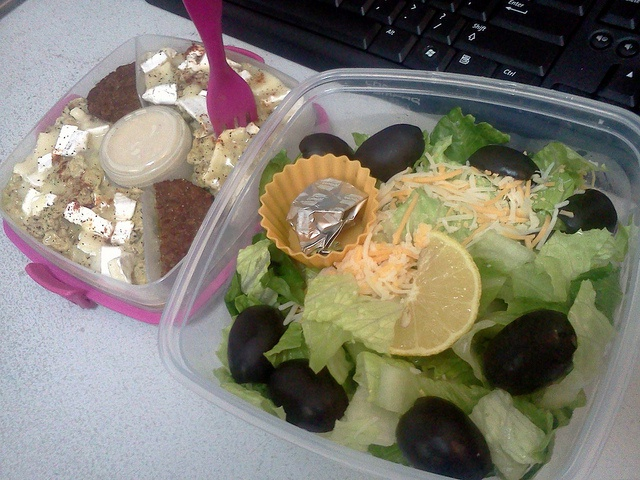Describe the objects in this image and their specific colors. I can see bowl in gray, tan, black, and darkgray tones, dining table in gray, darkgray, and lightgray tones, bowl in gray, darkgray, ivory, and tan tones, keyboard in gray, black, and darkgray tones, and orange in gray, tan, and khaki tones in this image. 